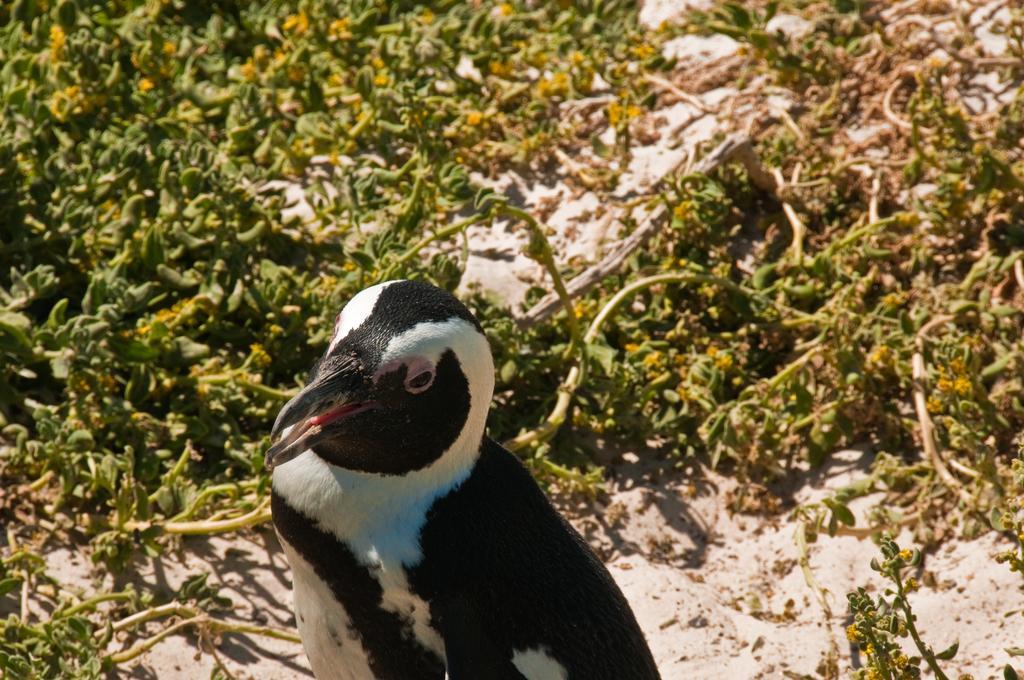How would you summarize this image in a sentence or two? In this image I see a penguin over here and I see the plants in the background. 